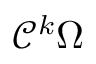Convert formula to latex. <formula><loc_0><loc_0><loc_500><loc_500>{ \mathcal { C } } ^ { k } \Omega</formula> 